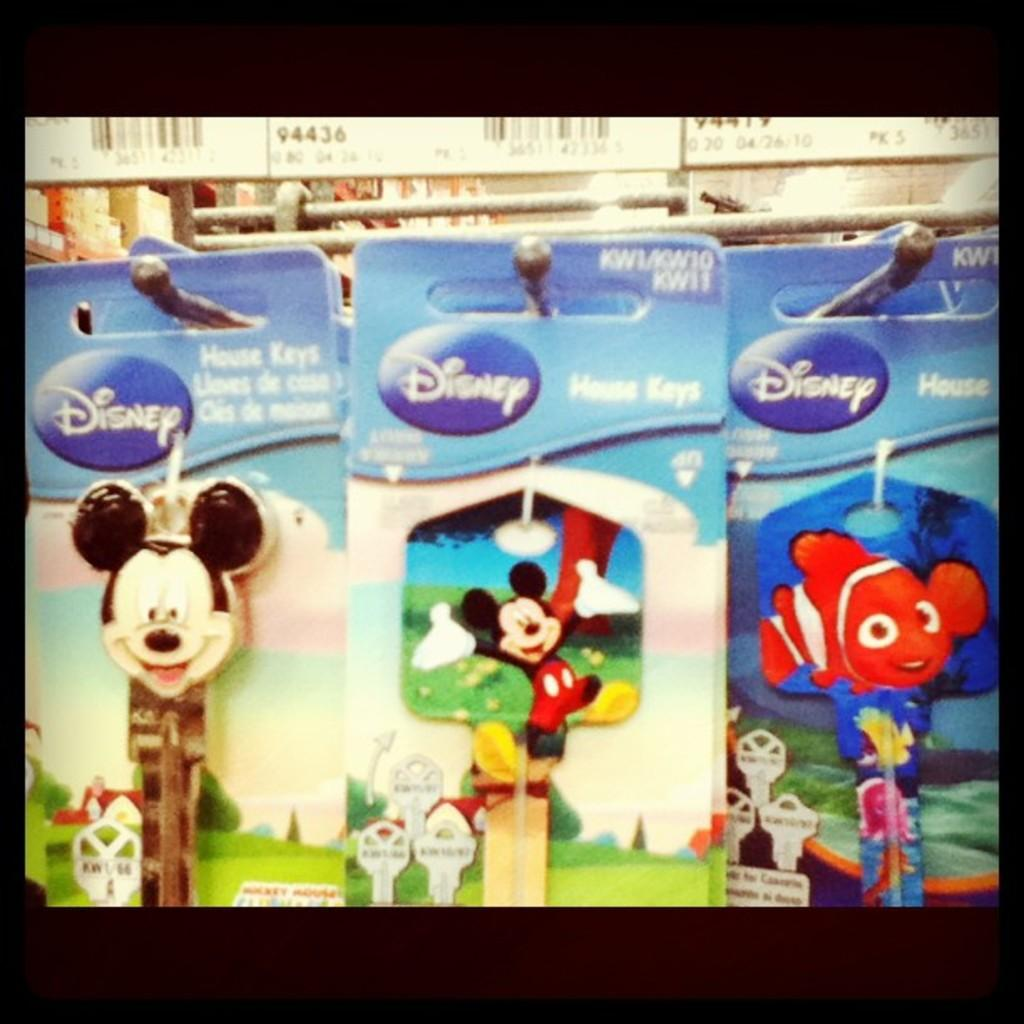What type of cards are featured in the image? There are Disney cards in the image. Who is depicted on the Disney cards? The Disney cards feature Mickey Mouse. How are the Disney cards displayed in the image? The cards are hanging on a hanger. What is located above the hanger in the image? There are barcode boards above the hanger. Where is the prison located in the image? There is no prison present in the image. What type of shelf is used to store the cards in the image? The cards are hanging on a hanger, not stored on a shelf, in the image. 